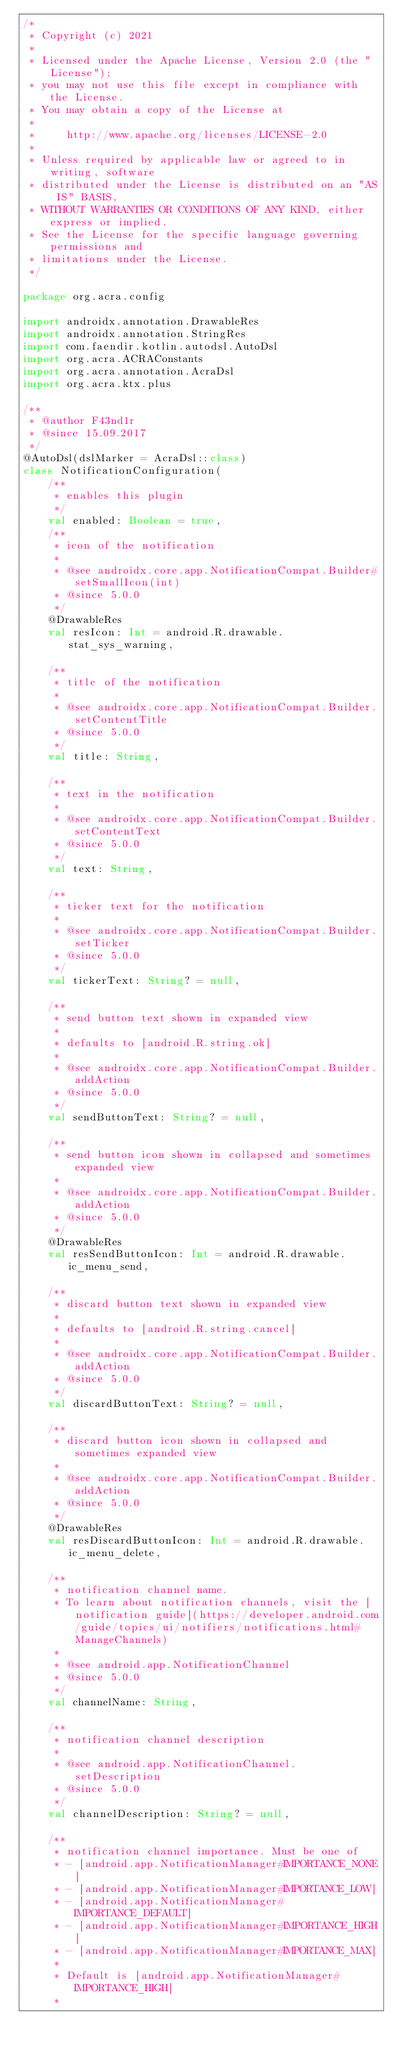Convert code to text. <code><loc_0><loc_0><loc_500><loc_500><_Kotlin_>/*
 * Copyright (c) 2021
 *
 * Licensed under the Apache License, Version 2.0 (the "License");
 * you may not use this file except in compliance with the License.
 * You may obtain a copy of the License at
 *
 *     http://www.apache.org/licenses/LICENSE-2.0
 *
 * Unless required by applicable law or agreed to in writing, software
 * distributed under the License is distributed on an "AS IS" BASIS,
 * WITHOUT WARRANTIES OR CONDITIONS OF ANY KIND, either express or implied.
 * See the License for the specific language governing permissions and
 * limitations under the License.
 */

package org.acra.config

import androidx.annotation.DrawableRes
import androidx.annotation.StringRes
import com.faendir.kotlin.autodsl.AutoDsl
import org.acra.ACRAConstants
import org.acra.annotation.AcraDsl
import org.acra.ktx.plus

/**
 * @author F43nd1r
 * @since 15.09.2017
 */
@AutoDsl(dslMarker = AcraDsl::class)
class NotificationConfiguration(
    /**
     * enables this plugin
     */
    val enabled: Boolean = true,
    /**
     * icon of the notification
     *
     * @see androidx.core.app.NotificationCompat.Builder#setSmallIcon(int)
     * @since 5.0.0
     */
    @DrawableRes
    val resIcon: Int = android.R.drawable.stat_sys_warning,

    /**
     * title of the notification
     *
     * @see androidx.core.app.NotificationCompat.Builder.setContentTitle
     * @since 5.0.0
     */
    val title: String,

    /**
     * text in the notification
     *
     * @see androidx.core.app.NotificationCompat.Builder.setContentText
     * @since 5.0.0
     */
    val text: String,

    /**
     * ticker text for the notification
     *
     * @see androidx.core.app.NotificationCompat.Builder.setTicker
     * @since 5.0.0
     */
    val tickerText: String? = null,

    /**
     * send button text shown in expanded view
     *
     * defaults to [android.R.string.ok]
     *
     * @see androidx.core.app.NotificationCompat.Builder.addAction
     * @since 5.0.0
     */
    val sendButtonText: String? = null,

    /**
     * send button icon shown in collapsed and sometimes expanded view
     *
     * @see androidx.core.app.NotificationCompat.Builder.addAction
     * @since 5.0.0
     */
    @DrawableRes
    val resSendButtonIcon: Int = android.R.drawable.ic_menu_send,

    /**
     * discard button text shown in expanded view
     *
     * defaults to [android.R.string.cancel]
     *
     * @see androidx.core.app.NotificationCompat.Builder.addAction
     * @since 5.0.0
     */
    val discardButtonText: String? = null,

    /**
     * discard button icon shown in collapsed and sometimes expanded view
     *
     * @see androidx.core.app.NotificationCompat.Builder.addAction
     * @since 5.0.0
     */
    @DrawableRes
    val resDiscardButtonIcon: Int = android.R.drawable.ic_menu_delete,

    /**
     * notification channel name.
     * To learn about notification channels, visit the [notification guide](https://developer.android.com/guide/topics/ui/notifiers/notifications.html#ManageChannels)
     *
     * @see android.app.NotificationChannel
     * @since 5.0.0
     */
    val channelName: String,

    /**
     * notification channel description
     *
     * @see android.app.NotificationChannel.setDescription
     * @since 5.0.0
     */
    val channelDescription: String? = null,

    /**
     * notification channel importance. Must be one of
     * - [android.app.NotificationManager#IMPORTANCE_NONE]
     * - [android.app.NotificationManager#IMPORTANCE_LOW]
     * - [android.app.NotificationManager#IMPORTANCE_DEFAULT]
     * - [android.app.NotificationManager#IMPORTANCE_HIGH]
     * - [android.app.NotificationManager#IMPORTANCE_MAX]
     *
     * Default is [android.app.NotificationManager#IMPORTANCE_HIGH]
     *</code> 